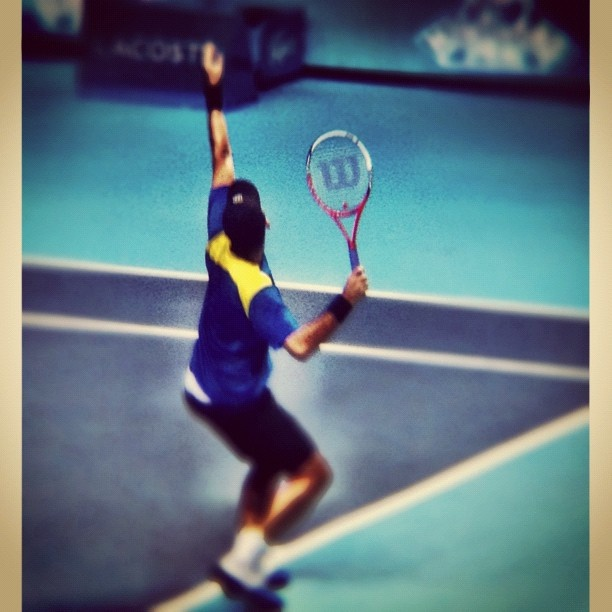Describe the objects in this image and their specific colors. I can see people in tan, black, navy, maroon, and gray tones and tennis racket in tan, teal, gray, darkgray, and violet tones in this image. 